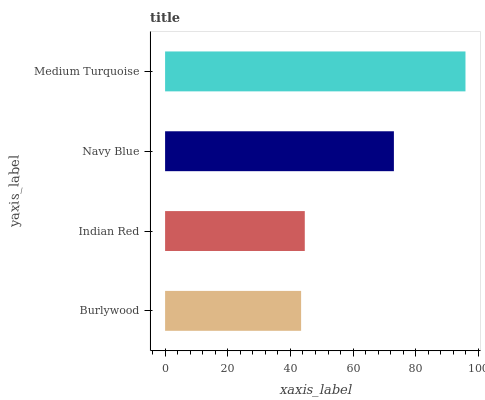Is Burlywood the minimum?
Answer yes or no. Yes. Is Medium Turquoise the maximum?
Answer yes or no. Yes. Is Indian Red the minimum?
Answer yes or no. No. Is Indian Red the maximum?
Answer yes or no. No. Is Indian Red greater than Burlywood?
Answer yes or no. Yes. Is Burlywood less than Indian Red?
Answer yes or no. Yes. Is Burlywood greater than Indian Red?
Answer yes or no. No. Is Indian Red less than Burlywood?
Answer yes or no. No. Is Navy Blue the high median?
Answer yes or no. Yes. Is Indian Red the low median?
Answer yes or no. Yes. Is Indian Red the high median?
Answer yes or no. No. Is Medium Turquoise the low median?
Answer yes or no. No. 